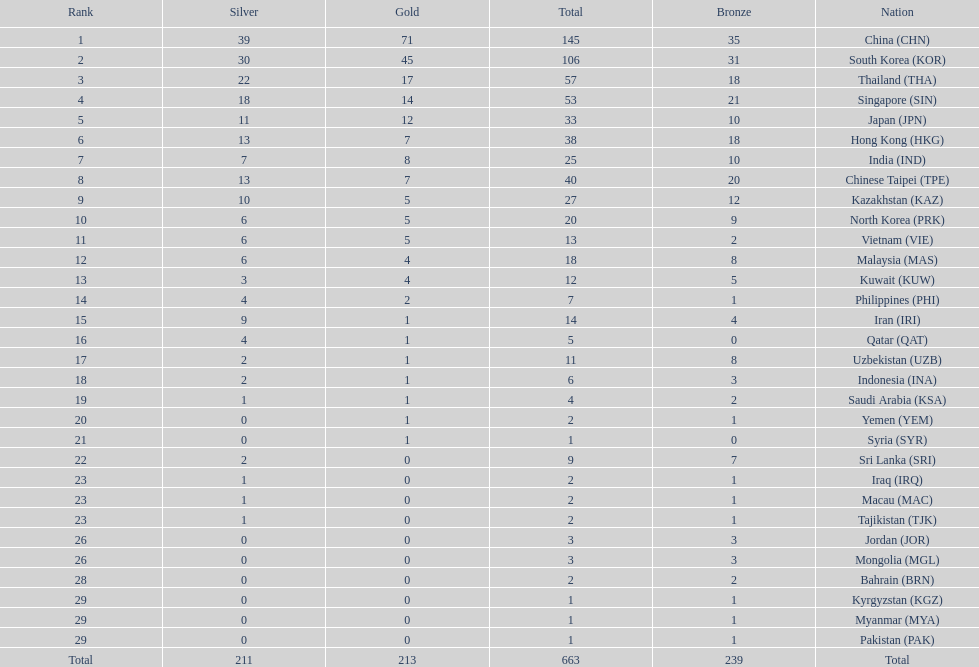What were the number of medals iran earned? 14. 